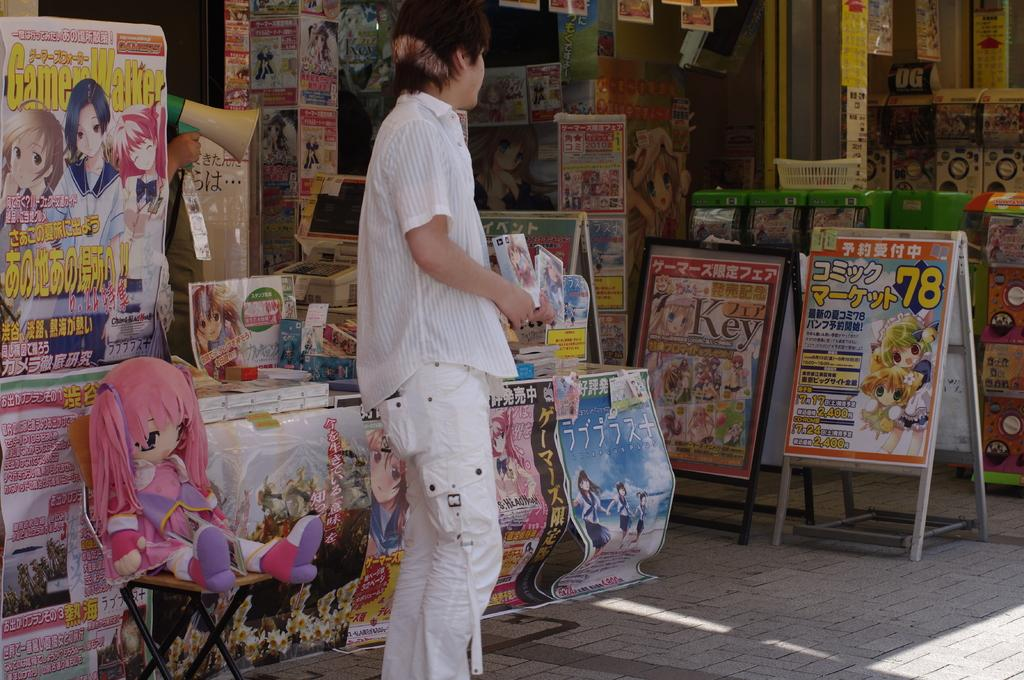<image>
Render a clear and concise summary of the photo. A sign on the sidewalk has 78 in yellow. 